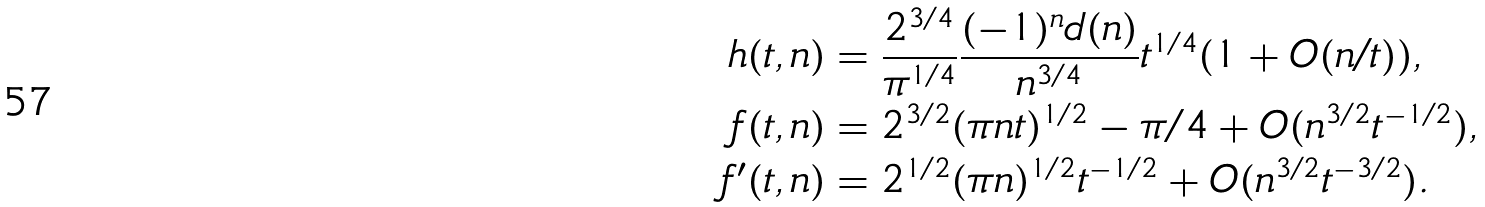<formula> <loc_0><loc_0><loc_500><loc_500>h ( t , n ) & = \frac { 2 ^ { 3 / 4 } } { \pi ^ { 1 / 4 } } \frac { ( - 1 ) ^ { n } d ( n ) } { n ^ { 3 / 4 } } t ^ { 1 / 4 } ( 1 + O ( n / t ) ) , \\ f ( t , n ) & = 2 ^ { 3 / 2 } ( \pi n t ) ^ { 1 / 2 } - \pi / 4 + O ( n ^ { 3 / 2 } t ^ { - 1 / 2 } ) , \\ f ^ { \prime } ( t , n ) & = 2 ^ { 1 / 2 } ( \pi n ) ^ { 1 / 2 } t ^ { - 1 / 2 } + O ( n ^ { 3 / 2 } t ^ { - 3 / 2 } ) .</formula> 